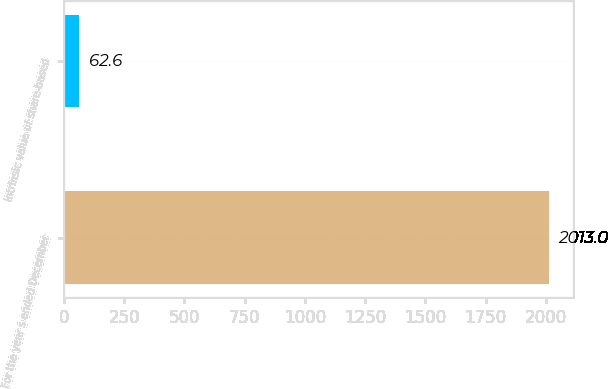<chart> <loc_0><loc_0><loc_500><loc_500><bar_chart><fcel>For the year s ended December<fcel>Intrinsic value of share-based<nl><fcel>2013<fcel>62.6<nl></chart> 